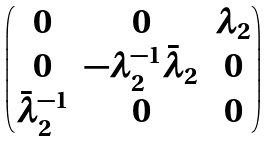<formula> <loc_0><loc_0><loc_500><loc_500>\begin{pmatrix} 0 & 0 & \lambda _ { 2 } \\ 0 & - \lambda _ { 2 } ^ { - 1 } \bar { \lambda } _ { 2 } & 0 \\ \bar { \lambda } _ { 2 } ^ { - 1 } & 0 & 0 \end{pmatrix}</formula> 